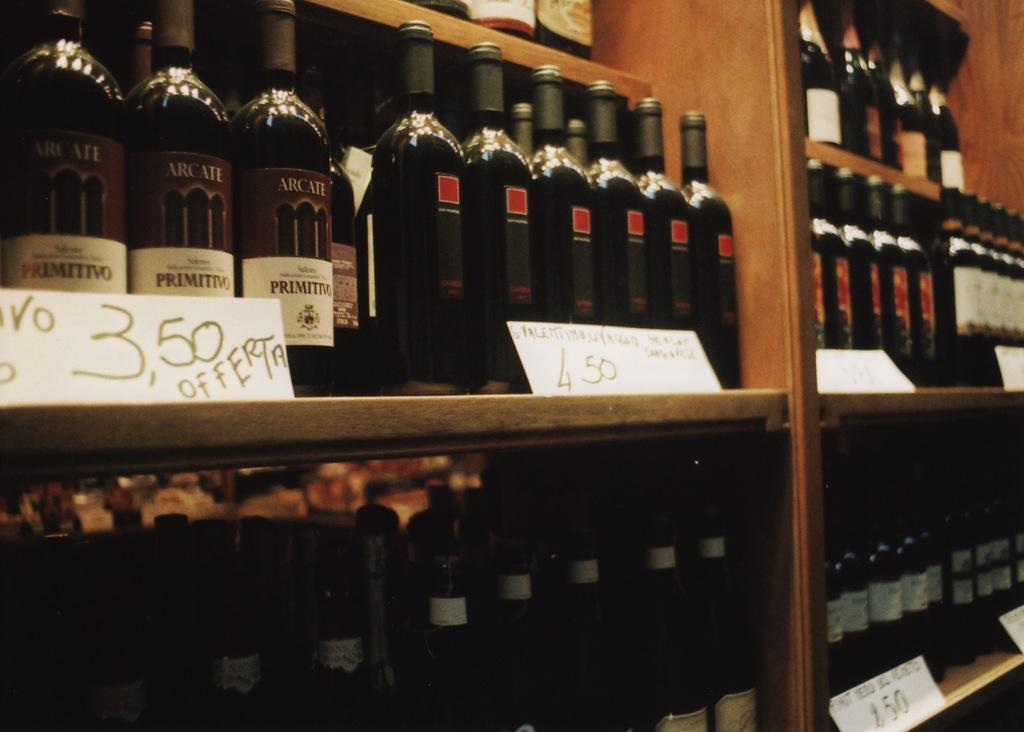Provide a one-sentence caption for the provided image. A selection of wines shows that one could buy the Arcate for 3.50. 